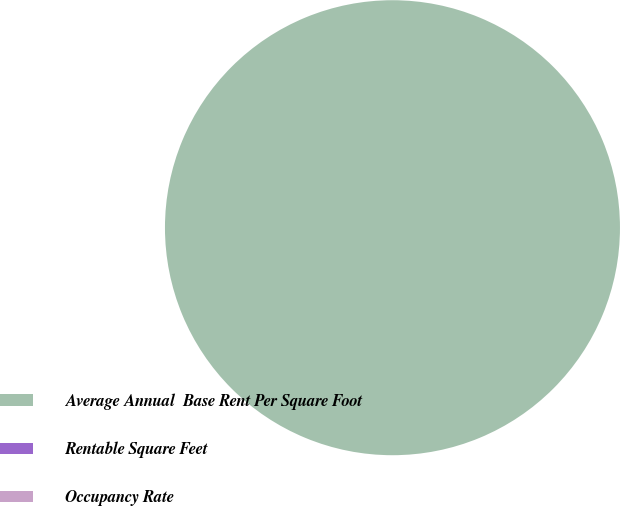Convert chart. <chart><loc_0><loc_0><loc_500><loc_500><pie_chart><fcel>Average Annual  Base Rent Per Square Foot<fcel>Rentable Square Feet<fcel>Occupancy Rate<nl><fcel>100.0%<fcel>0.0%<fcel>0.0%<nl></chart> 